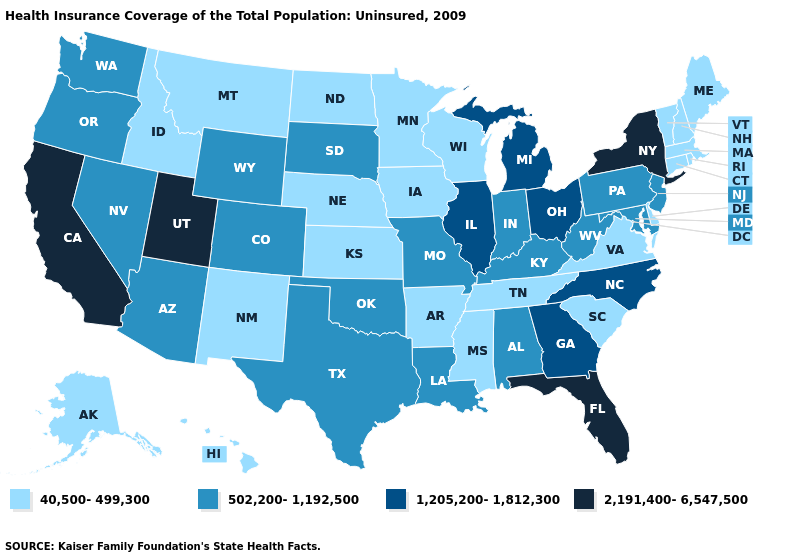Does the first symbol in the legend represent the smallest category?
Be succinct. Yes. What is the value of Alaska?
Quick response, please. 40,500-499,300. Which states have the highest value in the USA?
Give a very brief answer. California, Florida, New York, Utah. Which states have the highest value in the USA?
Short answer required. California, Florida, New York, Utah. Does the map have missing data?
Answer briefly. No. Among the states that border Oregon , does Idaho have the lowest value?
Be succinct. Yes. Which states have the lowest value in the USA?
Give a very brief answer. Alaska, Arkansas, Connecticut, Delaware, Hawaii, Idaho, Iowa, Kansas, Maine, Massachusetts, Minnesota, Mississippi, Montana, Nebraska, New Hampshire, New Mexico, North Dakota, Rhode Island, South Carolina, Tennessee, Vermont, Virginia, Wisconsin. Name the states that have a value in the range 40,500-499,300?
Be succinct. Alaska, Arkansas, Connecticut, Delaware, Hawaii, Idaho, Iowa, Kansas, Maine, Massachusetts, Minnesota, Mississippi, Montana, Nebraska, New Hampshire, New Mexico, North Dakota, Rhode Island, South Carolina, Tennessee, Vermont, Virginia, Wisconsin. What is the value of Utah?
Be succinct. 2,191,400-6,547,500. What is the value of Delaware?
Keep it brief. 40,500-499,300. What is the lowest value in the USA?
Answer briefly. 40,500-499,300. Does Oregon have the lowest value in the West?
Answer briefly. No. What is the value of Georgia?
Short answer required. 1,205,200-1,812,300. 